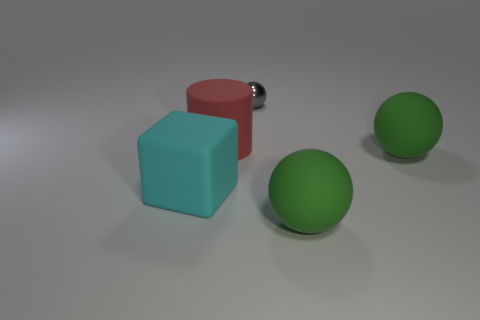What number of other cyan blocks have the same material as the block?
Your answer should be compact. 0. Is the number of gray things that are behind the tiny gray thing greater than the number of tiny blue objects?
Provide a short and direct response. No. Is there another gray object that has the same shape as the gray thing?
Offer a very short reply. No. What number of things are tiny gray balls or yellow rubber balls?
Provide a short and direct response. 1. There is a large thing that is in front of the thing on the left side of the red thing; what number of green rubber things are to the left of it?
Your answer should be compact. 0. What material is the big thing that is right of the red matte thing and behind the cyan block?
Make the answer very short. Rubber. Is the number of large red objects that are to the right of the small sphere less than the number of big red things in front of the large cyan cube?
Your answer should be compact. No. What number of other things are there of the same size as the gray object?
Keep it short and to the point. 0. The small gray object behind the green object that is left of the green matte thing behind the matte cube is what shape?
Ensure brevity in your answer.  Sphere. How many green objects are either matte objects or small things?
Make the answer very short. 2. 